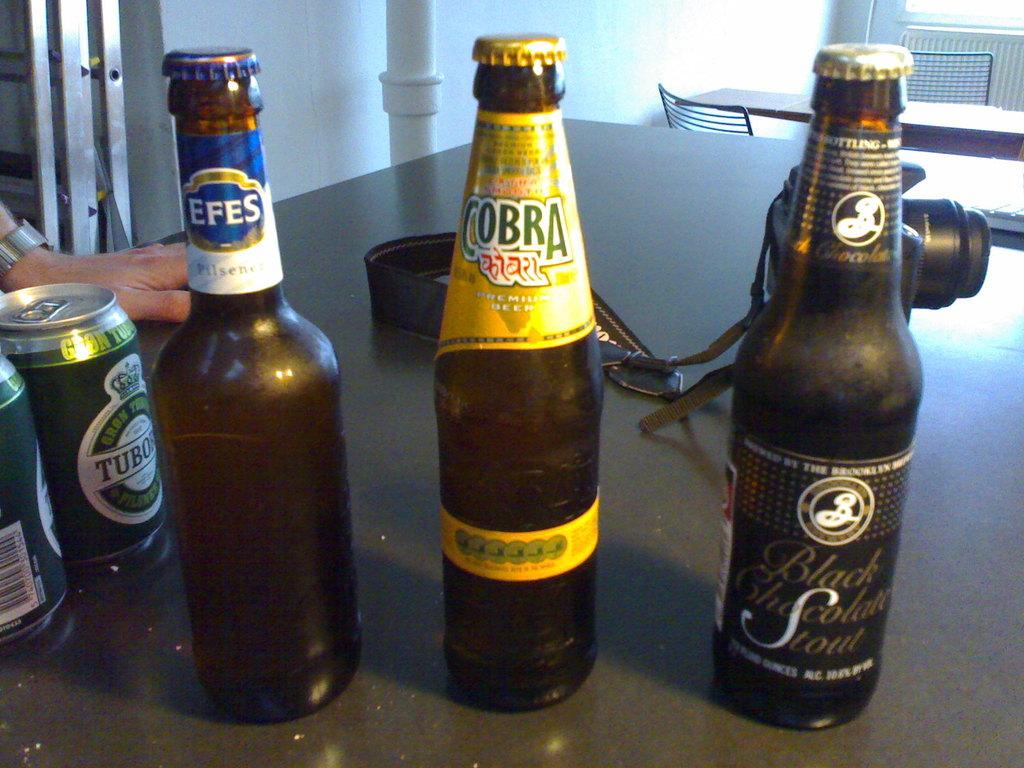What animal is listed on the yellow label?
Make the answer very short. Cobra. What is the drink in the bottle on the right?
Ensure brevity in your answer.  Black chocolate stout. 